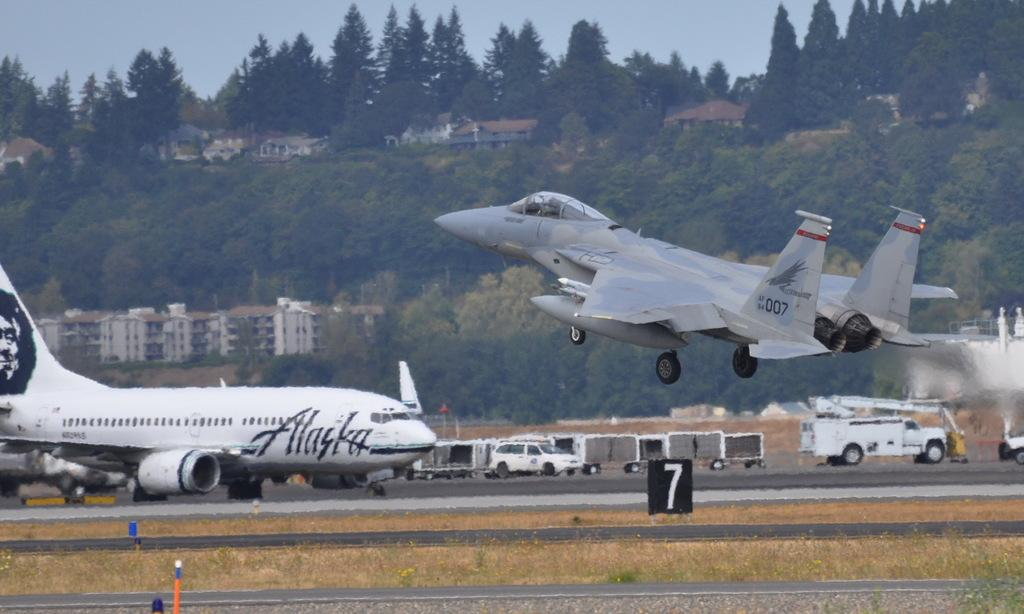Provide a one-sentence caption for the provided image. An Alaska plane is grounded as a jet takes off. 